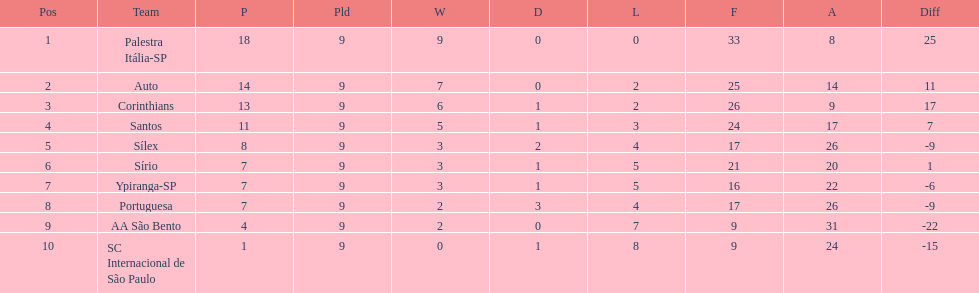Which brazilian team took the top spot in the 1926 brazilian football cup? Palestra Itália-SP. 